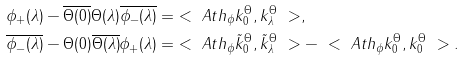<formula> <loc_0><loc_0><loc_500><loc_500>\phi _ { + } ( \lambda ) - \overline { \Theta ( 0 ) } \Theta ( \lambda ) \overline { \phi _ { - } ( \lambda ) } & = \ < \ A t h _ { \phi } k ^ { \Theta } _ { 0 } , k ^ { \Theta } _ { \lambda } \ > , \\ \overline { \phi _ { - } ( \lambda ) } - \Theta ( 0 ) \overline { \Theta ( \lambda ) } \phi _ { + } ( \lambda ) & = \ < \ A t h _ { \phi } \tilde { k } _ { 0 } ^ { \Theta } , \tilde { k } _ { \lambda } ^ { \Theta } \ > - \ < \ A t h _ { \phi } k _ { 0 } ^ { \Theta } , k _ { 0 } ^ { \Theta } \ > .</formula> 